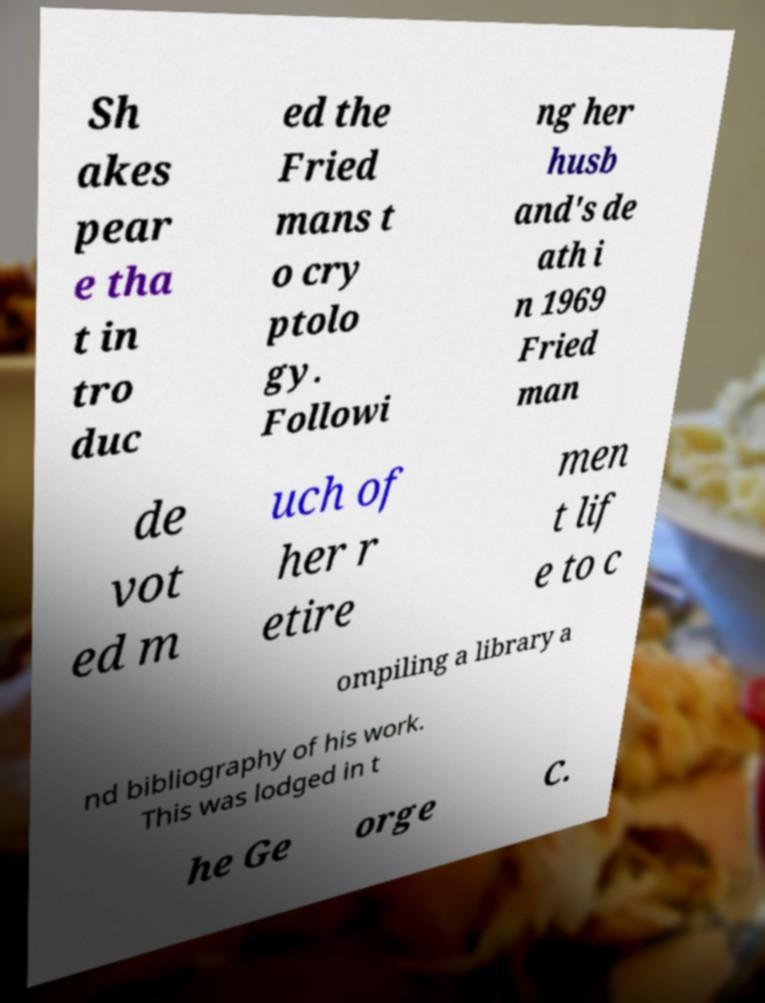Please identify and transcribe the text found in this image. Sh akes pear e tha t in tro duc ed the Fried mans t o cry ptolo gy. Followi ng her husb and's de ath i n 1969 Fried man de vot ed m uch of her r etire men t lif e to c ompiling a library a nd bibliography of his work. This was lodged in t he Ge orge C. 